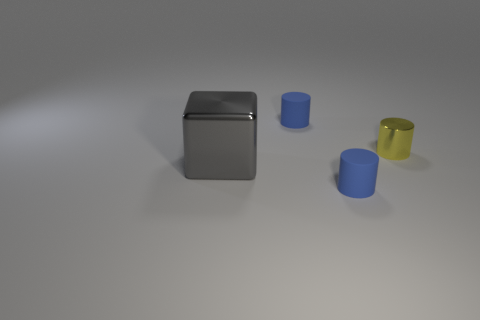How many small things are rubber objects or gray metal cubes?
Offer a very short reply. 2. Do the yellow thing and the metallic block have the same size?
Your response must be concise. No. What number of objects are either small rubber cylinders or small blue things in front of the yellow shiny thing?
Your response must be concise. 2. There is a large metallic block behind the object that is in front of the gray thing; what color is it?
Offer a terse response. Gray. Is the color of the small cylinder that is behind the yellow metallic thing the same as the large object?
Ensure brevity in your answer.  No. There is a blue cylinder behind the large gray shiny block; what material is it?
Your answer should be compact. Rubber. What size is the metallic cylinder?
Provide a succinct answer. Small. Is the material of the tiny blue object that is in front of the block the same as the big gray block?
Give a very brief answer. No. How many tiny rubber objects are there?
Ensure brevity in your answer.  2. What number of things are either large blocks or large red metallic balls?
Offer a terse response. 1. 